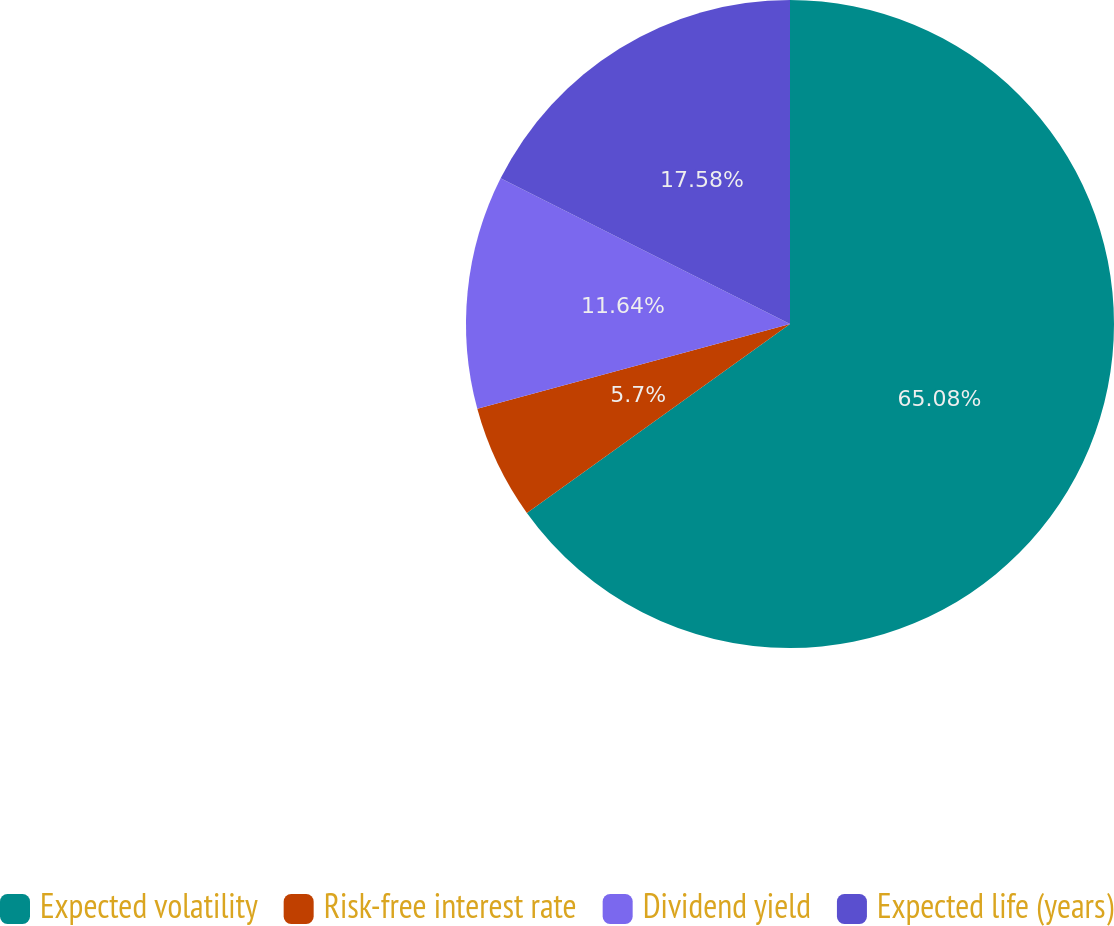<chart> <loc_0><loc_0><loc_500><loc_500><pie_chart><fcel>Expected volatility<fcel>Risk-free interest rate<fcel>Dividend yield<fcel>Expected life (years)<nl><fcel>65.09%<fcel>5.7%<fcel>11.64%<fcel>17.58%<nl></chart> 